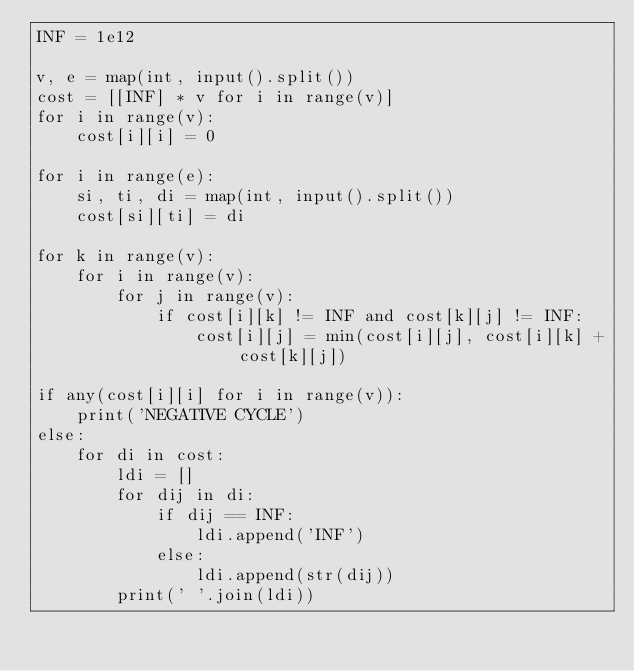Convert code to text. <code><loc_0><loc_0><loc_500><loc_500><_Python_>INF = 1e12

v, e = map(int, input().split())
cost = [[INF] * v for i in range(v)]
for i in range(v):
    cost[i][i] = 0

for i in range(e):
    si, ti, di = map(int, input().split())
    cost[si][ti] = di

for k in range(v):
    for i in range(v):
        for j in range(v):
            if cost[i][k] != INF and cost[k][j] != INF:
                cost[i][j] = min(cost[i][j], cost[i][k] + cost[k][j])

if any(cost[i][i] for i in range(v)):
    print('NEGATIVE CYCLE')
else:
    for di in cost:
        ldi = []
        for dij in di:
            if dij == INF:
                ldi.append('INF')
            else:
                ldi.append(str(dij))
        print(' '.join(ldi))</code> 